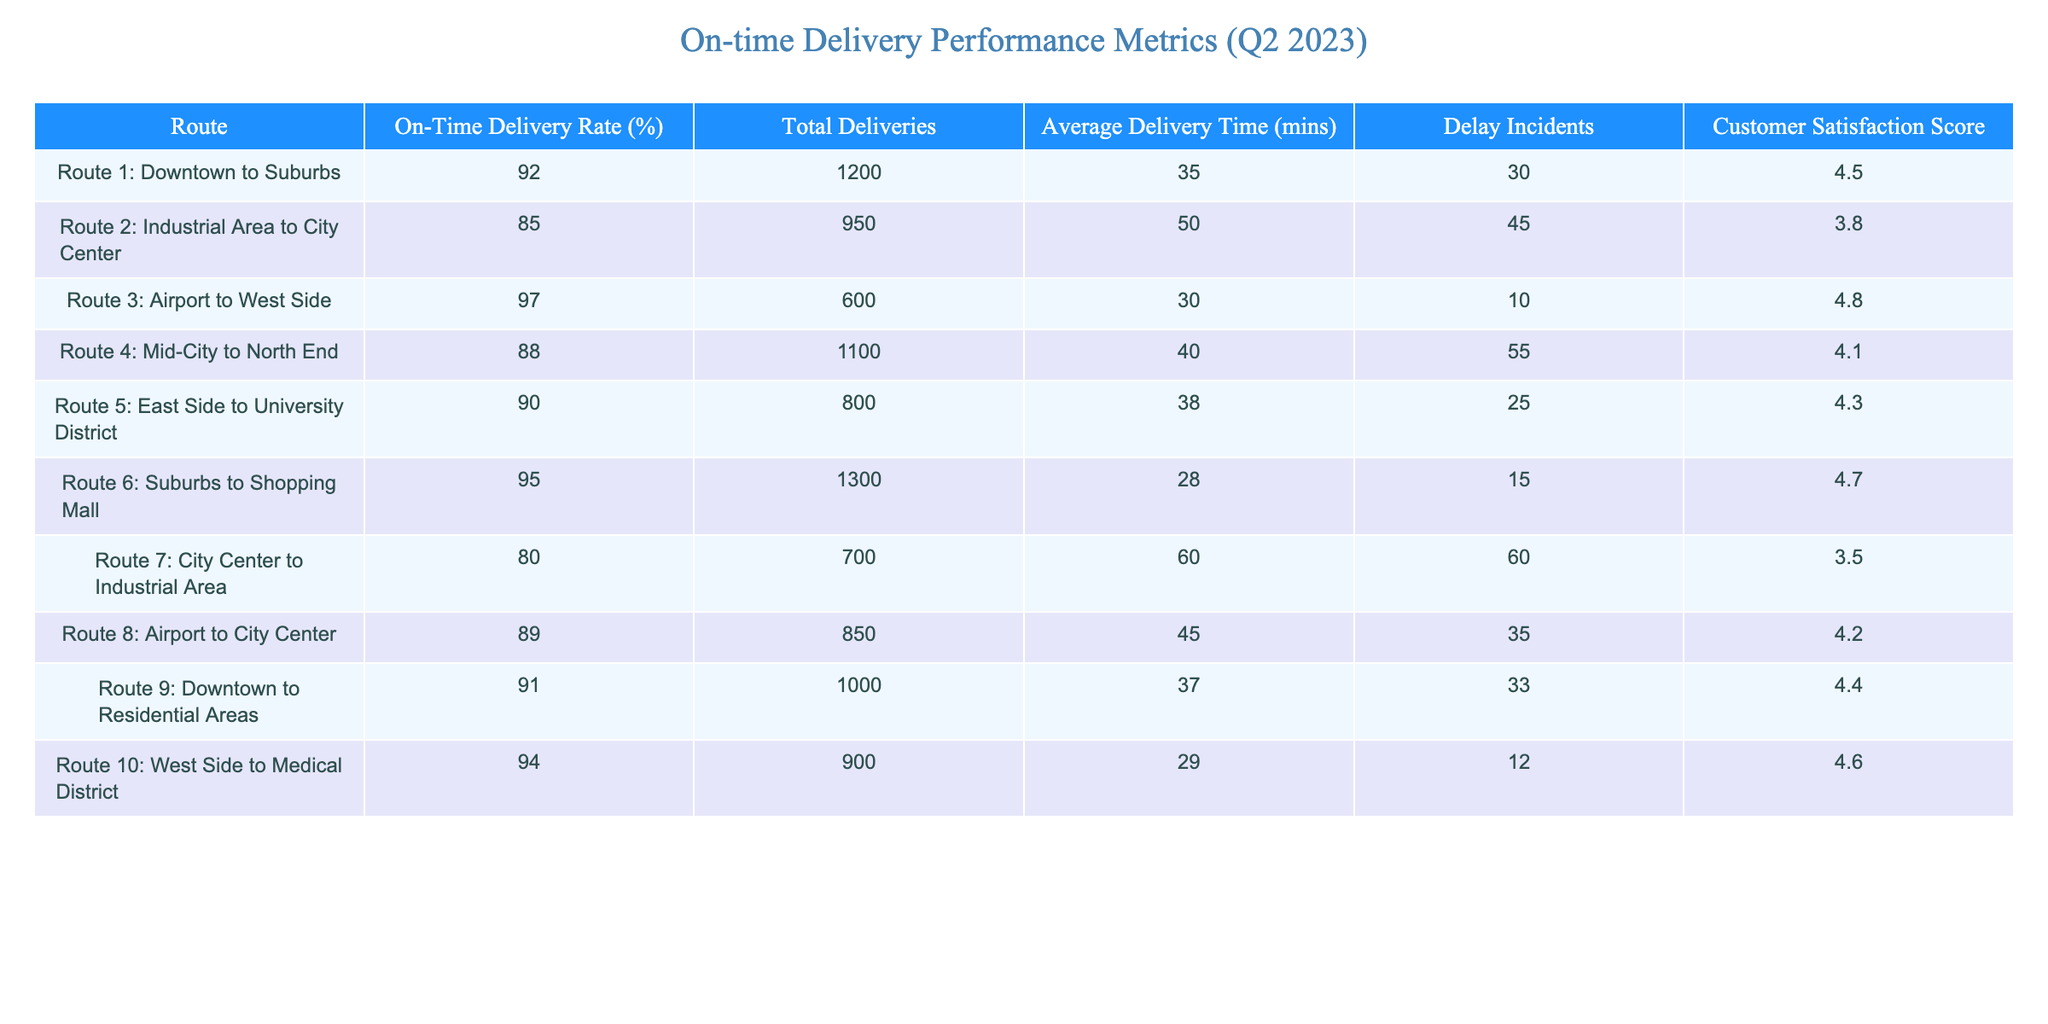What is the on-time delivery rate for Route 3? The on-time delivery rate is listed directly in the table for each route, and for Route 3: Airport to West Side, it is 97%.
Answer: 97% Which route had the highest customer satisfaction score? To find the highest customer satisfaction score, I need to scan through the scores for all routes. The highest score found is 4.8 for Route 3: Airport to West Side.
Answer: 4.8 How many total deliveries were made on Route 1? The table shows that Route 1: Downtown to Suburbs had a total of 1200 deliveries.
Answer: 1200 What is the average delivery time for Route 6? The average delivery time for each route is provided in the table, and Route 6: Suburbs to Shopping Mall has an average delivery time of 28 minutes.
Answer: 28 minutes Which route experienced the most delay incidents? Looking at the Delay Incidents column, Route 7: City Center to Industrial Area had the highest number of incidents, with a total of 60 delays.
Answer: 60 What percentage of deliveries were on time for Route 4? The on-time delivery rate for Route 4: Mid-City to North End is found in the table and is recorded as 88%.
Answer: 88% Calculate the difference in on-time delivery rates between Route 1 and Route 2. The on-time delivery rate for Route 1 is 92% and for Route 2 it's 85%. The difference is 92% - 85% = 7%.
Answer: 7% Is the customer satisfaction score for Route 10 higher than that of Route 2? The customer satisfaction score for Route 10: West Side to Medical District is 4.6 while Route 2: Industrial Area to City Center has a score of 3.8. Therefore, it is true that Route 10 has a higher score.
Answer: Yes What is the average delivery time for routes with an on-time delivery rate of 90% or higher? The routes with an on-time delivery rate of 90% or higher are Route 1 (35 mins), Route 3 (30 mins), Route 5 (38 mins), and Route 6 (28 mins). Their average is calculated as (35 + 30 + 38 + 28) / 4 = 32.75 minutes.
Answer: 32.75 minutes Which route has the lowest on-time delivery rate, and what is that rate? Scanning through the On-Time Delivery Rate column, Route 7: City Center to Industrial Area has the lowest rate at 80%.
Answer: 80% 